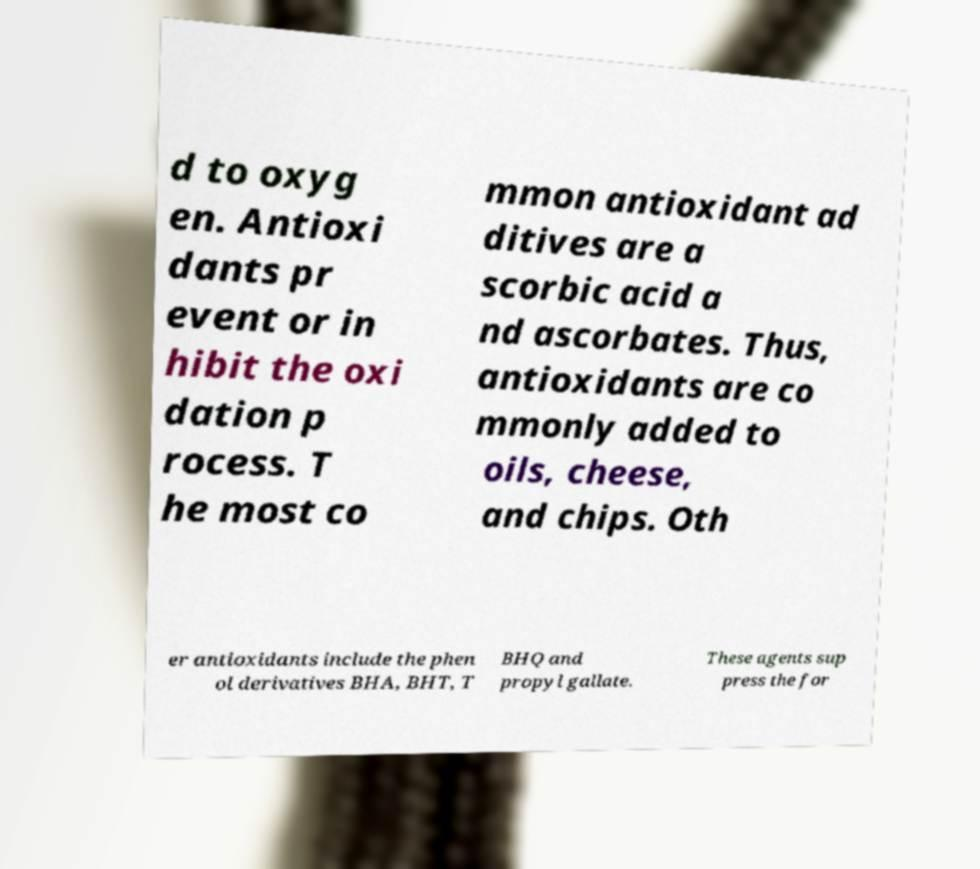For documentation purposes, I need the text within this image transcribed. Could you provide that? d to oxyg en. Antioxi dants pr event or in hibit the oxi dation p rocess. T he most co mmon antioxidant ad ditives are a scorbic acid a nd ascorbates. Thus, antioxidants are co mmonly added to oils, cheese, and chips. Oth er antioxidants include the phen ol derivatives BHA, BHT, T BHQ and propyl gallate. These agents sup press the for 